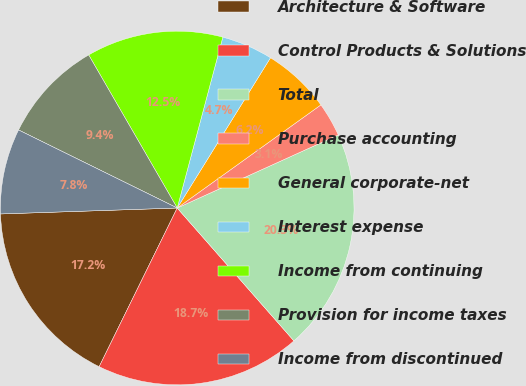<chart> <loc_0><loc_0><loc_500><loc_500><pie_chart><fcel>Architecture & Software<fcel>Control Products & Solutions<fcel>Total<fcel>Purchase accounting<fcel>General corporate-net<fcel>Interest expense<fcel>Income from continuing<fcel>Provision for income taxes<fcel>Income from discontinued<nl><fcel>17.19%<fcel>18.75%<fcel>20.31%<fcel>3.13%<fcel>6.25%<fcel>4.69%<fcel>12.5%<fcel>9.38%<fcel>7.81%<nl></chart> 